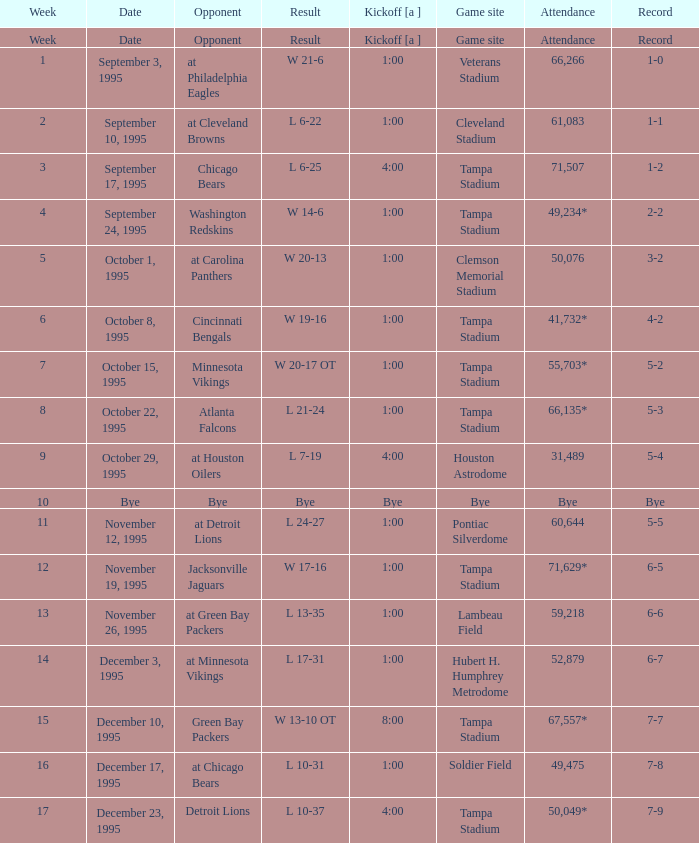Could you parse the entire table? {'header': ['Week', 'Date', 'Opponent', 'Result', 'Kickoff [a ]', 'Game site', 'Attendance', 'Record'], 'rows': [['Week', 'Date', 'Opponent', 'Result', 'Kickoff [a ]', 'Game site', 'Attendance', 'Record'], ['1', 'September 3, 1995', 'at Philadelphia Eagles', 'W 21-6', '1:00', 'Veterans Stadium', '66,266', '1-0'], ['2', 'September 10, 1995', 'at Cleveland Browns', 'L 6-22', '1:00', 'Cleveland Stadium', '61,083', '1-1'], ['3', 'September 17, 1995', 'Chicago Bears', 'L 6-25', '4:00', 'Tampa Stadium', '71,507', '1-2'], ['4', 'September 24, 1995', 'Washington Redskins', 'W 14-6', '1:00', 'Tampa Stadium', '49,234*', '2-2'], ['5', 'October 1, 1995', 'at Carolina Panthers', 'W 20-13', '1:00', 'Clemson Memorial Stadium', '50,076', '3-2'], ['6', 'October 8, 1995', 'Cincinnati Bengals', 'W 19-16', '1:00', 'Tampa Stadium', '41,732*', '4-2'], ['7', 'October 15, 1995', 'Minnesota Vikings', 'W 20-17 OT', '1:00', 'Tampa Stadium', '55,703*', '5-2'], ['8', 'October 22, 1995', 'Atlanta Falcons', 'L 21-24', '1:00', 'Tampa Stadium', '66,135*', '5-3'], ['9', 'October 29, 1995', 'at Houston Oilers', 'L 7-19', '4:00', 'Houston Astrodome', '31,489', '5-4'], ['10', 'Bye', 'Bye', 'Bye', 'Bye', 'Bye', 'Bye', 'Bye'], ['11', 'November 12, 1995', 'at Detroit Lions', 'L 24-27', '1:00', 'Pontiac Silverdome', '60,644', '5-5'], ['12', 'November 19, 1995', 'Jacksonville Jaguars', 'W 17-16', '1:00', 'Tampa Stadium', '71,629*', '6-5'], ['13', 'November 26, 1995', 'at Green Bay Packers', 'L 13-35', '1:00', 'Lambeau Field', '59,218', '6-6'], ['14', 'December 3, 1995', 'at Minnesota Vikings', 'L 17-31', '1:00', 'Hubert H. Humphrey Metrodome', '52,879', '6-7'], ['15', 'December 10, 1995', 'Green Bay Packers', 'W 13-10 OT', '8:00', 'Tampa Stadium', '67,557*', '7-7'], ['16', 'December 17, 1995', 'at Chicago Bears', 'L 10-31', '1:00', 'Soldier Field', '49,475', '7-8'], ['17', 'December 23, 1995', 'Detroit Lions', 'L 10-37', '4:00', 'Tampa Stadium', '50,049*', '7-9']]} Who did the Tampa Bay Buccaneers play on december 23, 1995? Detroit Lions. 